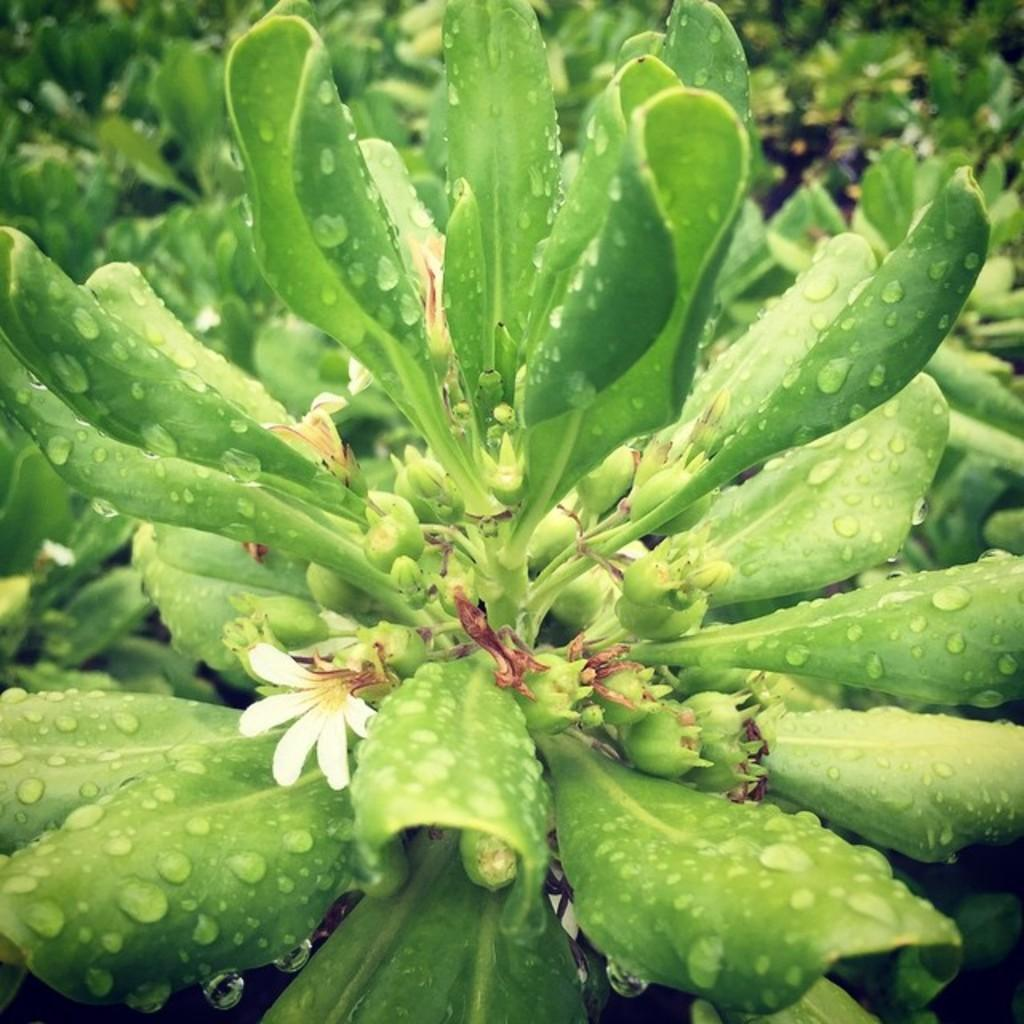What type of plant is in the image? There is a green color plant in the image. Are there any flowers on the plant? Yes, there is a small white color flower on the plant. What type of hand can be seen holding the plant in the image? There is no hand visible in the image; it only shows the plant and the small white color flower. 